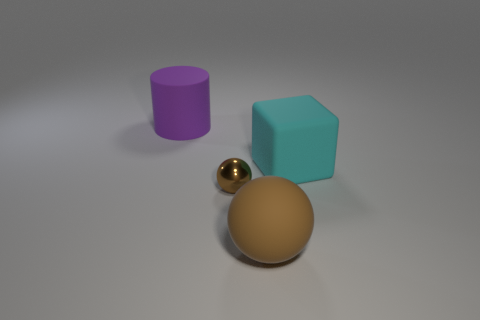Add 2 rubber balls. How many objects exist? 6 Subtract all cylinders. How many objects are left? 3 Add 4 large spheres. How many large spheres are left? 5 Add 1 purple cylinders. How many purple cylinders exist? 2 Subtract 0 purple spheres. How many objects are left? 4 Subtract all gray rubber balls. Subtract all big things. How many objects are left? 1 